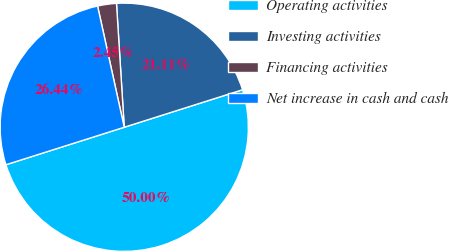Convert chart. <chart><loc_0><loc_0><loc_500><loc_500><pie_chart><fcel>Operating activities<fcel>Investing activities<fcel>Financing activities<fcel>Net increase in cash and cash<nl><fcel>50.0%<fcel>21.11%<fcel>2.45%<fcel>26.44%<nl></chart> 